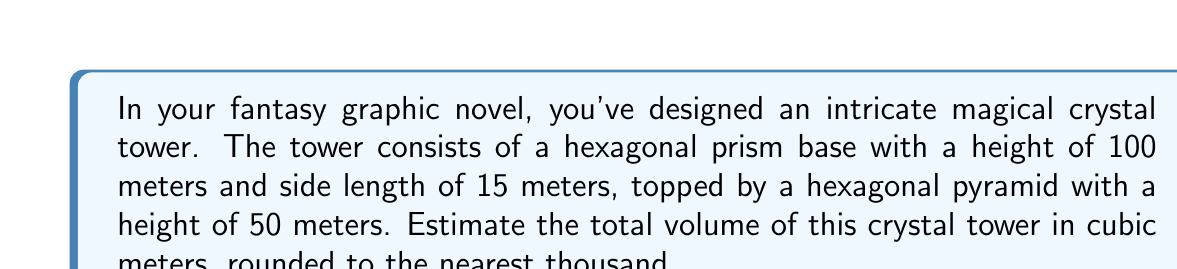Help me with this question. To estimate the volume of the crystal tower, we need to calculate the volumes of the hexagonal prism and the hexagonal pyramid separately, then add them together.

1. Volume of the hexagonal prism (base):
   The formula for the volume of a hexagonal prism is:
   $$V_{prism} = \frac{3\sqrt{3}}{2}s^2h$$
   Where $s$ is the side length and $h$ is the height.

   Substituting the values:
   $$V_{prism} = \frac{3\sqrt{3}}{2} \cdot 15^2 \cdot 100 \approx 58,424.77 \text{ m}^3$$

2. Volume of the hexagonal pyramid (top):
   The formula for the volume of a hexagonal pyramid is:
   $$V_{pyramid} = \frac{1}{3} \cdot \frac{3\sqrt{3}}{2}s^2h$$
   Where $s$ is the side length of the base and $h$ is the height of the pyramid.

   Substituting the values:
   $$V_{pyramid} = \frac{1}{3} \cdot \frac{3\sqrt{3}}{2} \cdot 15^2 \cdot 50 \approx 9,737.46 \text{ m}^3$$

3. Total volume:
   $$V_{total} = V_{prism} + V_{pyramid} \approx 58,424.77 + 9,737.46 = 68,162.23 \text{ m}^3$$

Rounding to the nearest thousand:
$$V_{total} \approx 68,000 \text{ m}^3$$
Answer: 68,000 cubic meters 